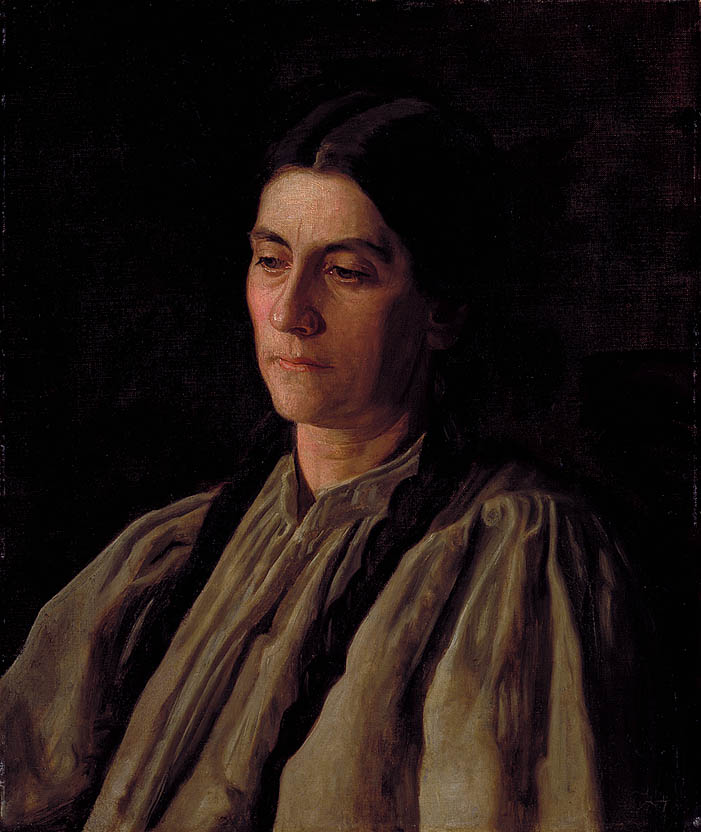What is this photo about? The painting you are referring to is an evocative impressionist portrait of a middle-aged woman. The artist employs a subdued palette dominated by dark tones, using the contrast with the woman's light cream blouse to draw attention to her contemplative expression. This artistic choice elevates the emotional weight of the scene, possibly reflecting the subject's inner thoughts or societal position during the period. The impressionist technique, with its characteristic loose brushstrokes, not only captures the physical likeness but also imparts a sense of the psychological and emotional state of the subject. The painting invites viewers to ponder over the woman's life story, her thoughts, and the circumstances that might have led to this moment captured in time. 